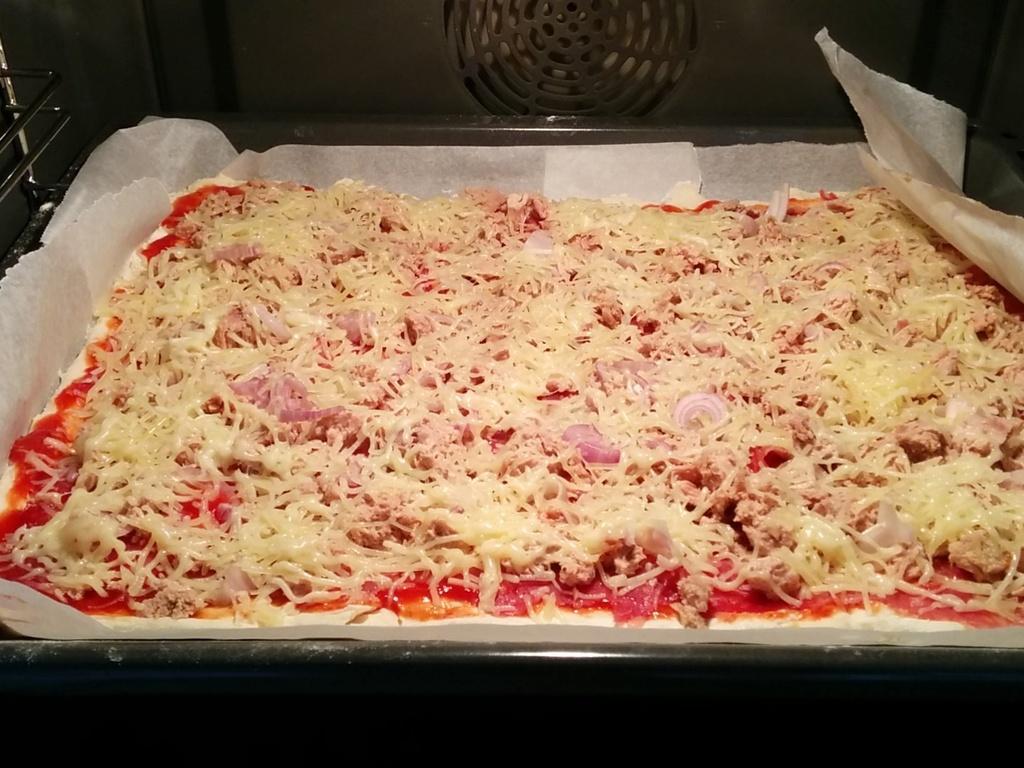In one or two sentences, can you explain what this image depicts? In this picture we can see a tray, there is some food and a paper present in this tray. 